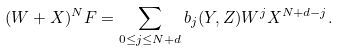<formula> <loc_0><loc_0><loc_500><loc_500>( W + X ) ^ { N } F = \sum _ { 0 \leq j \leq N + d } b _ { j } ( Y , Z ) W ^ { j } X ^ { N + d - j } .</formula> 